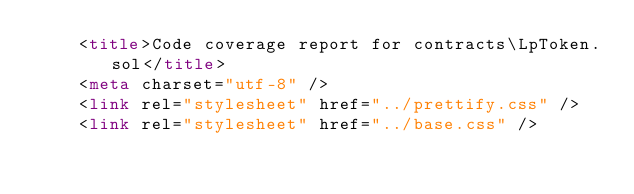<code> <loc_0><loc_0><loc_500><loc_500><_HTML_>    <title>Code coverage report for contracts\LpToken.sol</title>
    <meta charset="utf-8" />
    <link rel="stylesheet" href="../prettify.css" />
    <link rel="stylesheet" href="../base.css" /></code> 